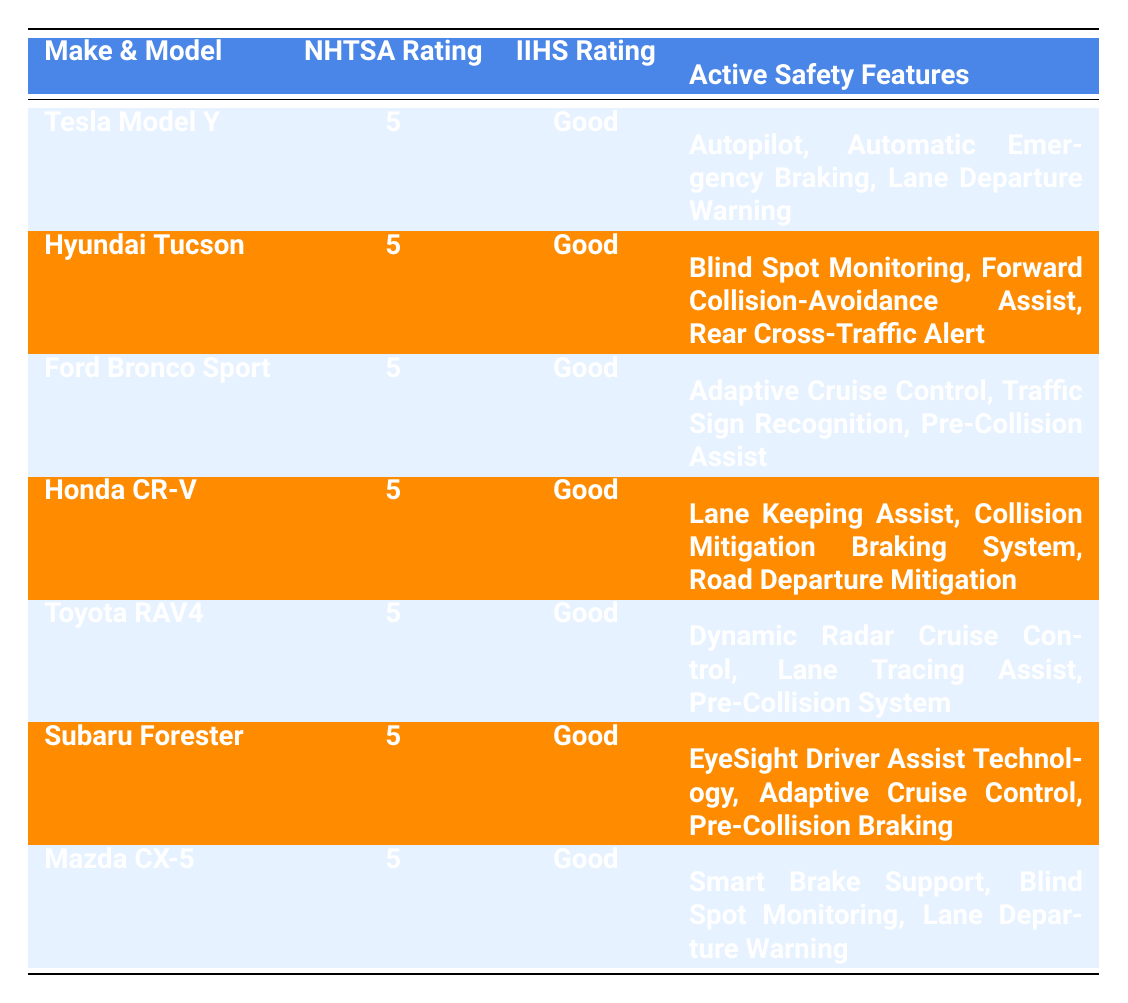What is the NHTSA rating for the Tesla Model Y? The table indicates that the NHTSA rating for the Tesla Model Y is listed directly under the NHTSA Rating column. According to the data, it shows a rating of 5.
Answer: 5 Which car models have a "Good" IIHS rating? The IIHS Rating column shows that all listed car models (Tesla Model Y, Hyundai Tucson, Ford Bronco Sport, Honda CR-V, Toyota RAV4, Subaru Forester, and Mazda CX-5) have a "Good" rating. This can be confirmed by reading down the IIHS Rating column.
Answer: Tesla Model Y, Hyundai Tucson, Ford Bronco Sport, Honda CR-V, Toyota RAV4, Subaru Forester, Mazda CX-5 How many unique active safety features are listed in the table? By examining the Active Safety Features column, the following unique features are observed: Autopilot, Automatic Emergency Braking, Lane Departure Warning, Blind Spot Monitoring, Forward Collision-Avoidance Assist, Rear Cross-Traffic Alert, Adaptive Cruise Control, Traffic Sign Recognition, Pre-Collision Assist, Lane Keeping Assist, Collision Mitigation Braking System, Road Departure Mitigation, Dynamic Radar Cruise Control, Lane Tracing Assist, Pre-Collision System, EyeSight Driver Assist Technology, Smart Brake Support. Counting these gives a total of 17 unique features.
Answer: 17 Are there any car models with both lane departure warning and blind spot monitoring features? By inspecting the Active Safety Features of each model, it can be determined that the Mazda CX-5 has Lane Departure Warning and the Hyundai Tucson has Blind Spot Monitoring. However, no model has both features. This conclusion is reached by checking each model's features for overlap.
Answer: No Which car has the highest number of active safety features? Each model's features are tallied: Tesla Model Y (3), Hyundai Tucson (3), Ford Bronco Sport (3), Honda CR-V (3), Toyota RAV4 (3), Subaru Forester (3), and Mazda CX-5 (3). All car models have the same count of 3 features. Hence, there is no single car with more features, as they are equal.
Answer: None, all have 3 features What is the average NHTSA rating for the cars listed in the table? All listed cars have an NHTSA rating of 5. Adding these ratings (5+5+5+5+5+5+5 = 35) and dividing by the total number of cars (7), the calculation yields an average NHTSA rating of 5 (35/7).
Answer: 5 Does the Subaru Forester have Adaptive Cruise Control as part of its safety features? By looking at the Active Safety Features for the Subaru Forester, it clearly indicates that it includes Adaptive Cruise Control among its features. This is a direct confirmation from the table.
Answer: Yes Which make and model does not include lane keeping assist as a safety feature? Upon checking the Active Safety Features of each entry, the Ford Bronco Sport does not list Lane Keeping Assist among its features, while the others (Honda CR-V and Mazda CX-5) do. This requires comparing each model's listed features to find the absence of lane keeping assist.
Answer: Ford Bronco Sport 